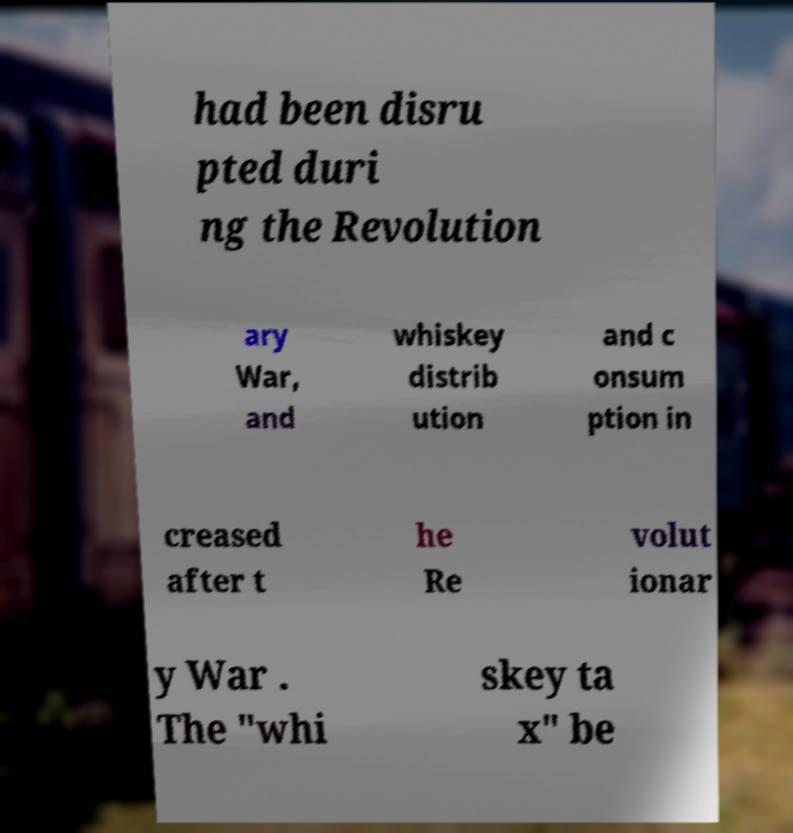Can you accurately transcribe the text from the provided image for me? had been disru pted duri ng the Revolution ary War, and whiskey distrib ution and c onsum ption in creased after t he Re volut ionar y War . The "whi skey ta x" be 